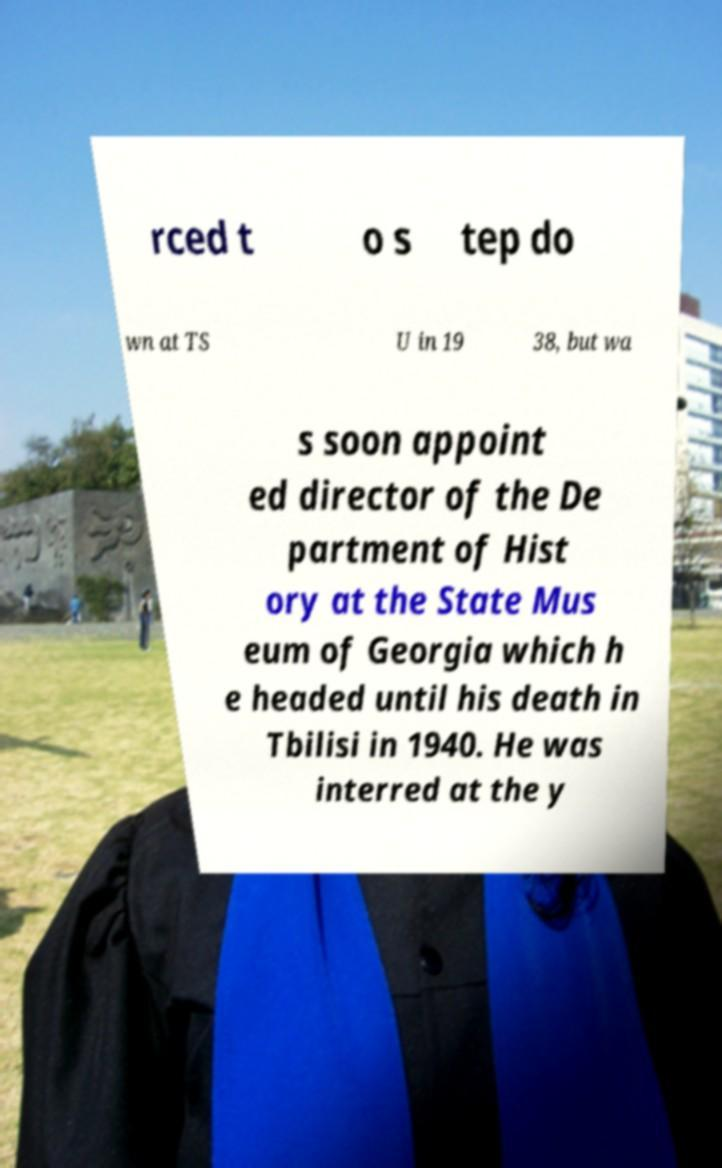Can you read and provide the text displayed in the image?This photo seems to have some interesting text. Can you extract and type it out for me? rced t o s tep do wn at TS U in 19 38, but wa s soon appoint ed director of the De partment of Hist ory at the State Mus eum of Georgia which h e headed until his death in Tbilisi in 1940. He was interred at the y 